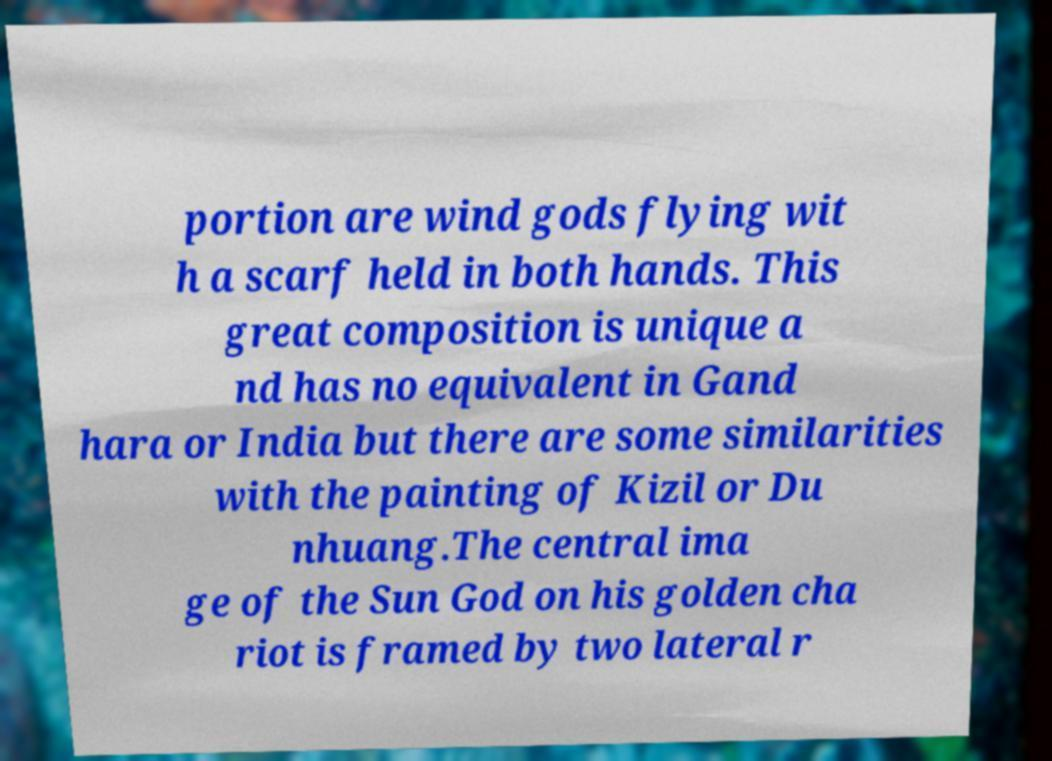Can you accurately transcribe the text from the provided image for me? portion are wind gods flying wit h a scarf held in both hands. This great composition is unique a nd has no equivalent in Gand hara or India but there are some similarities with the painting of Kizil or Du nhuang.The central ima ge of the Sun God on his golden cha riot is framed by two lateral r 